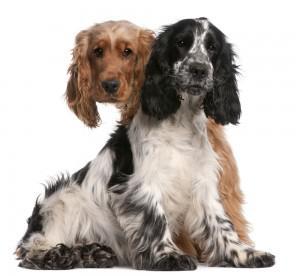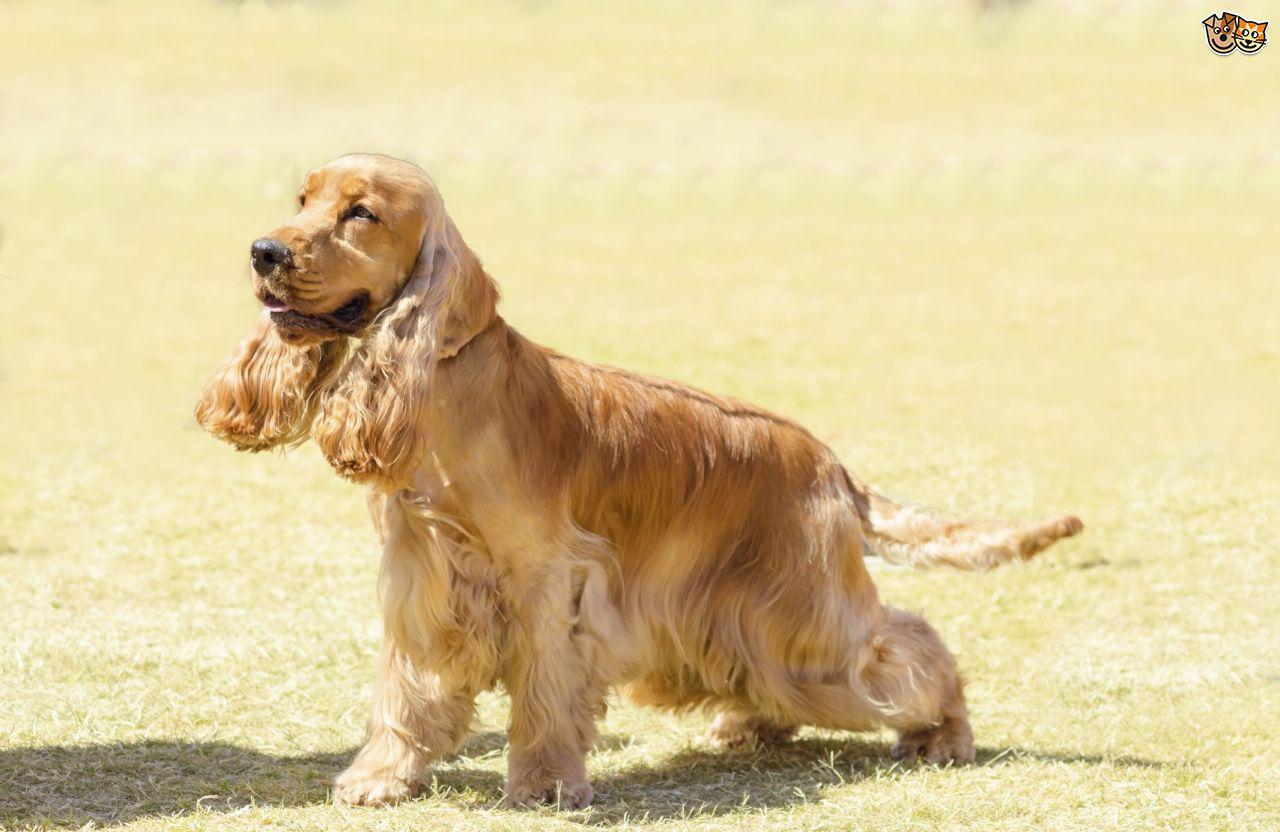The first image is the image on the left, the second image is the image on the right. Evaluate the accuracy of this statement regarding the images: "There is at least one dog with some black fur.". Is it true? Answer yes or no. Yes. The first image is the image on the left, the second image is the image on the right. Assess this claim about the two images: "There are two dogs facing forward with their tongues out in the image on the right.". Correct or not? Answer yes or no. No. 